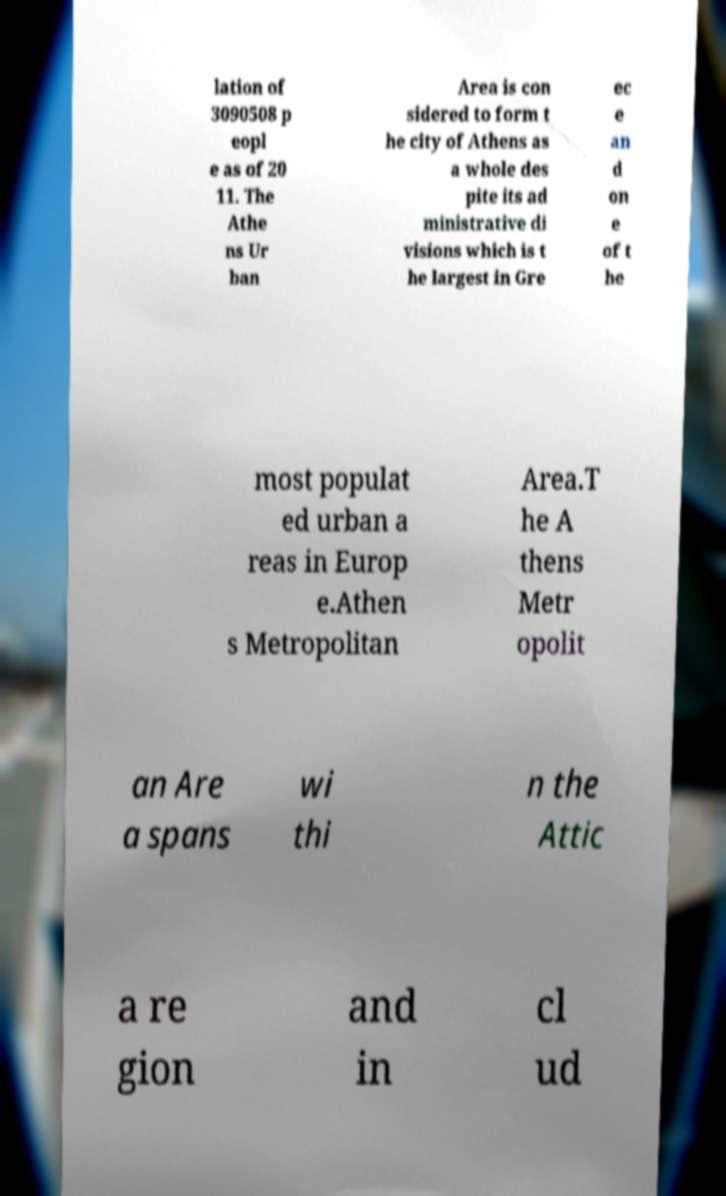Please identify and transcribe the text found in this image. lation of 3090508 p eopl e as of 20 11. The Athe ns Ur ban Area is con sidered to form t he city of Athens as a whole des pite its ad ministrative di visions which is t he largest in Gre ec e an d on e of t he most populat ed urban a reas in Europ e.Athen s Metropolitan Area.T he A thens Metr opolit an Are a spans wi thi n the Attic a re gion and in cl ud 